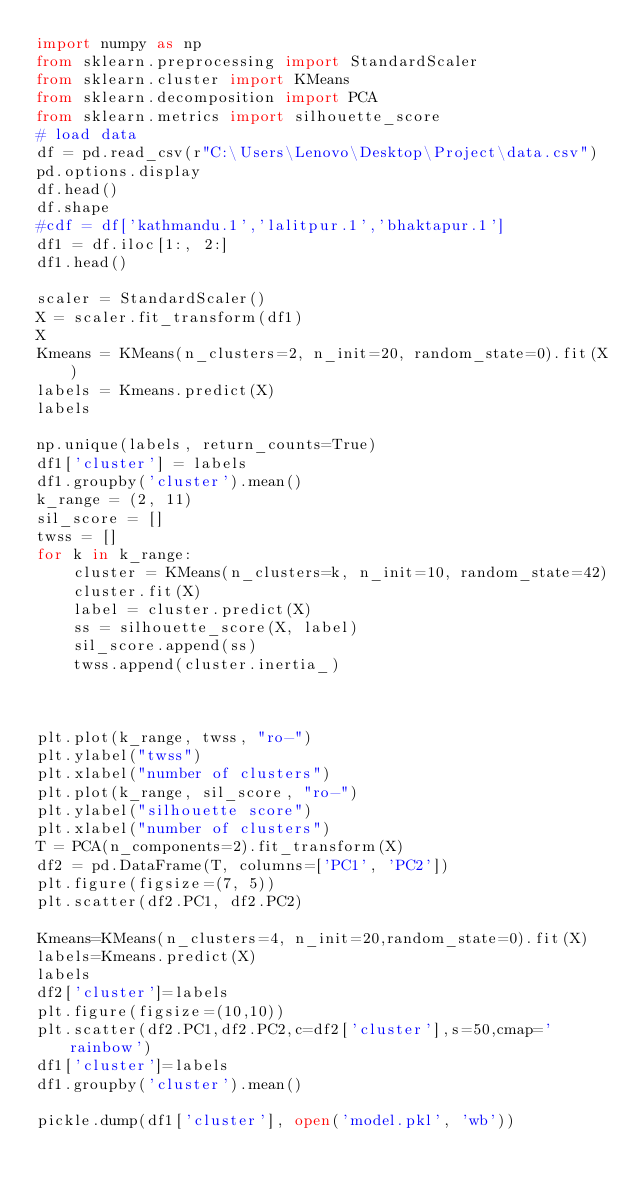Convert code to text. <code><loc_0><loc_0><loc_500><loc_500><_Python_>import numpy as np
from sklearn.preprocessing import StandardScaler
from sklearn.cluster import KMeans
from sklearn.decomposition import PCA
from sklearn.metrics import silhouette_score
# load data
df = pd.read_csv(r"C:\Users\Lenovo\Desktop\Project\data.csv")
pd.options.display
df.head()
df.shape
#cdf = df['kathmandu.1','lalitpur.1','bhaktapur.1']
df1 = df.iloc[1:, 2:]
df1.head()

scaler = StandardScaler()
X = scaler.fit_transform(df1)
X
Kmeans = KMeans(n_clusters=2, n_init=20, random_state=0).fit(X)
labels = Kmeans.predict(X)
labels

np.unique(labels, return_counts=True)
df1['cluster'] = labels
df1.groupby('cluster').mean()
k_range = (2, 11)
sil_score = []
twss = []
for k in k_range:
    cluster = KMeans(n_clusters=k, n_init=10, random_state=42)
    cluster.fit(X)
    label = cluster.predict(X)
    ss = silhouette_score(X, label)
    sil_score.append(ss)
    twss.append(cluster.inertia_)
    


plt.plot(k_range, twss, "ro-")
plt.ylabel("twss")
plt.xlabel("number of clusters")
plt.plot(k_range, sil_score, "ro-")
plt.ylabel("silhouette score")
plt.xlabel("number of clusters")
T = PCA(n_components=2).fit_transform(X)
df2 = pd.DataFrame(T, columns=['PC1', 'PC2'])
plt.figure(figsize=(7, 5))
plt.scatter(df2.PC1, df2.PC2)

Kmeans=KMeans(n_clusters=4, n_init=20,random_state=0).fit(X)
labels=Kmeans.predict(X)
labels
df2['cluster']=labels
plt.figure(figsize=(10,10))
plt.scatter(df2.PC1,df2.PC2,c=df2['cluster'],s=50,cmap='rainbow')
df1['cluster']=labels
df1.groupby('cluster').mean()

pickle.dump(df1['cluster'], open('model.pkl', 'wb'))
</code> 